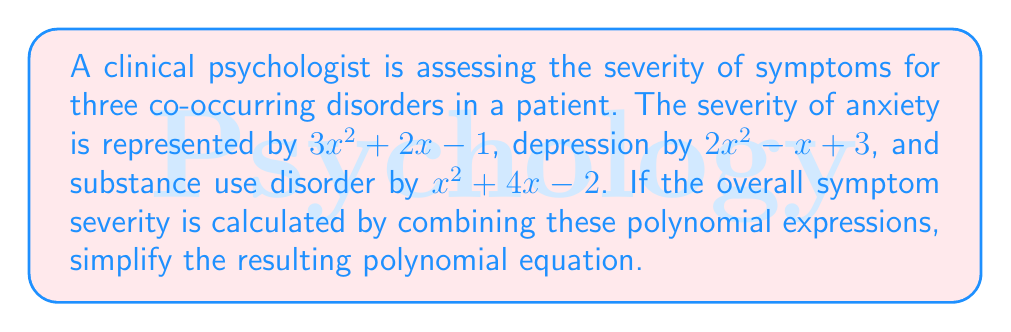Show me your answer to this math problem. To simplify the polynomial equation representing the overall symptom severity, we need to add the three polynomial expressions together. Let's do this step-by-step:

1. Combine like terms:
   - $x^2$ terms: $(3x^2) + (2x^2) + (x^2) = 6x^2$
   - $x$ terms: $(2x) + (-x) + (4x) = 5x$
   - Constant terms: $(-1) + (3) + (-2) = 0$

2. Write the simplified polynomial:
   $$6x^2 + 5x + 0$$

3. Since adding 0 doesn't change the value, we can omit it:
   $$6x^2 + 5x$$

This simplified polynomial represents the overall symptom severity for the patient's co-occurring disorders.
Answer: $6x^2 + 5x$ 